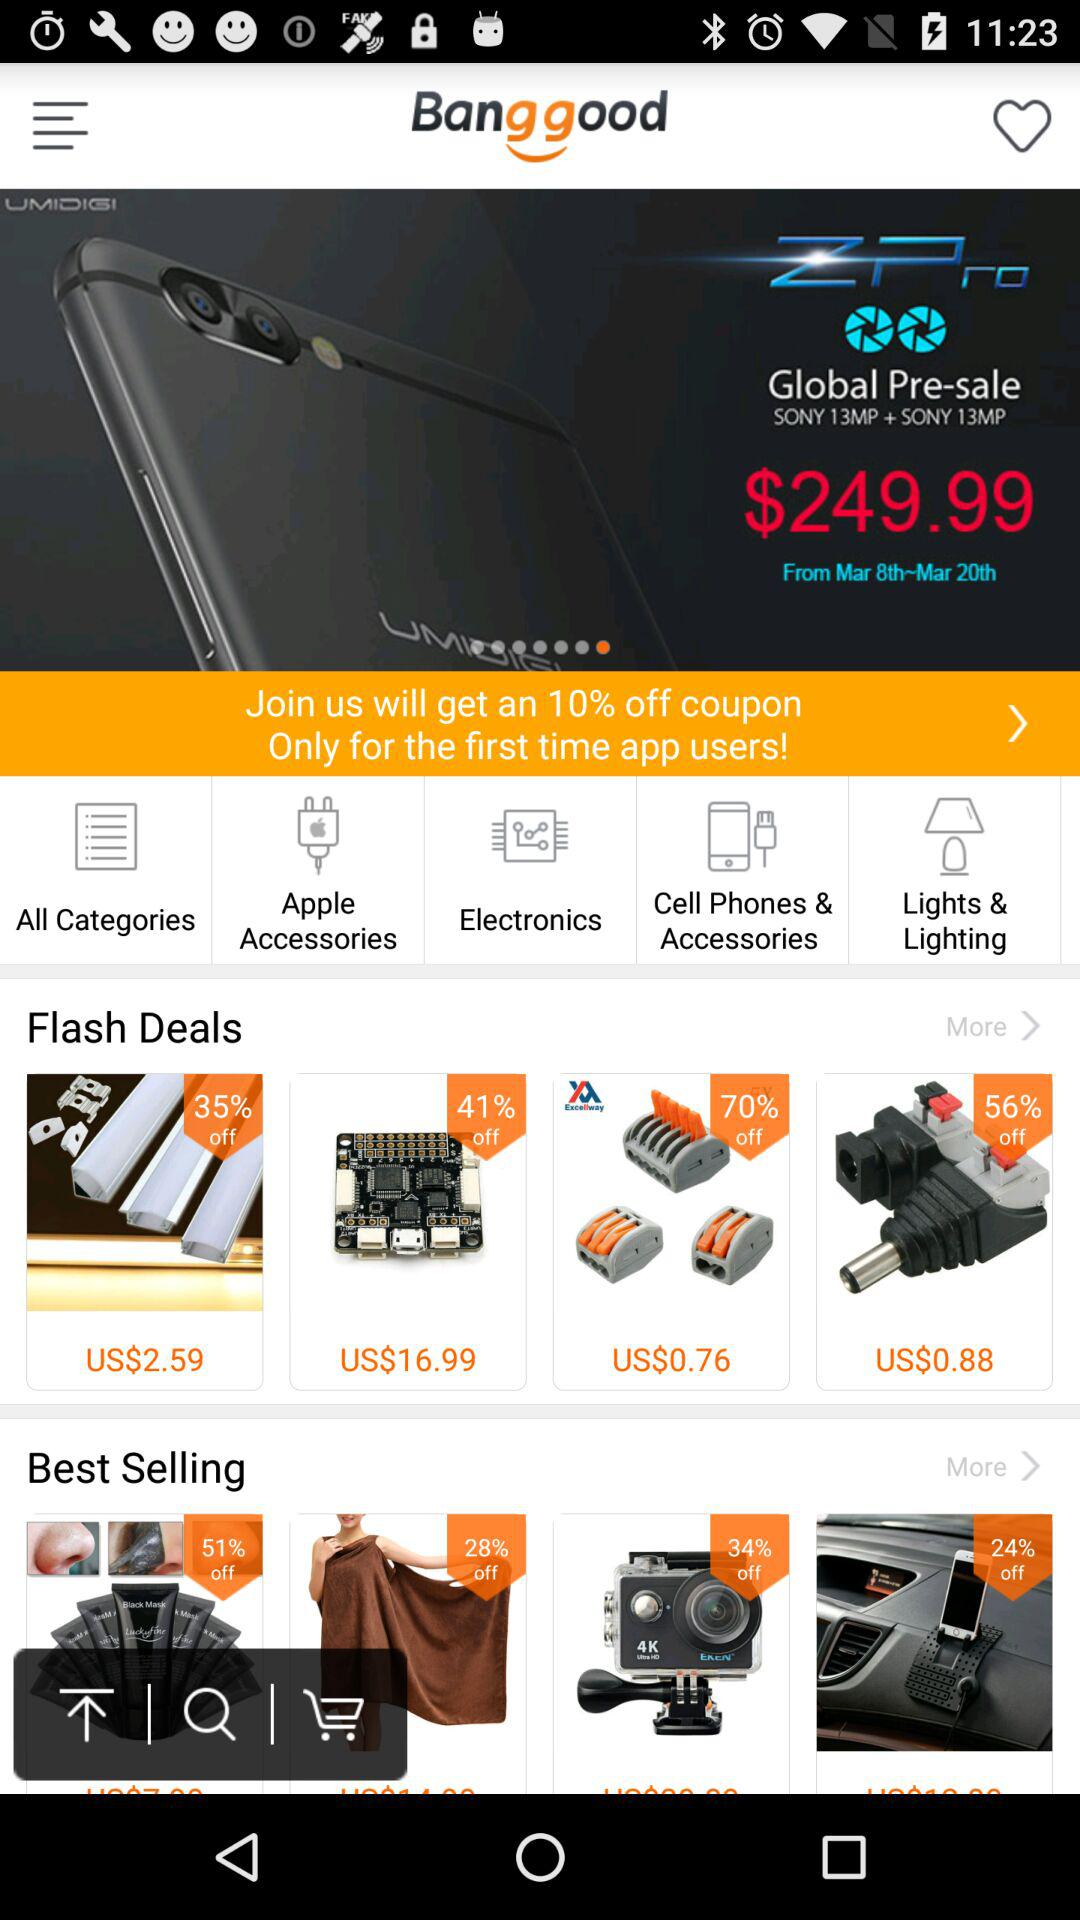When does the sale start for Z Pro? The sale starts for Z Pro on March 8th. 